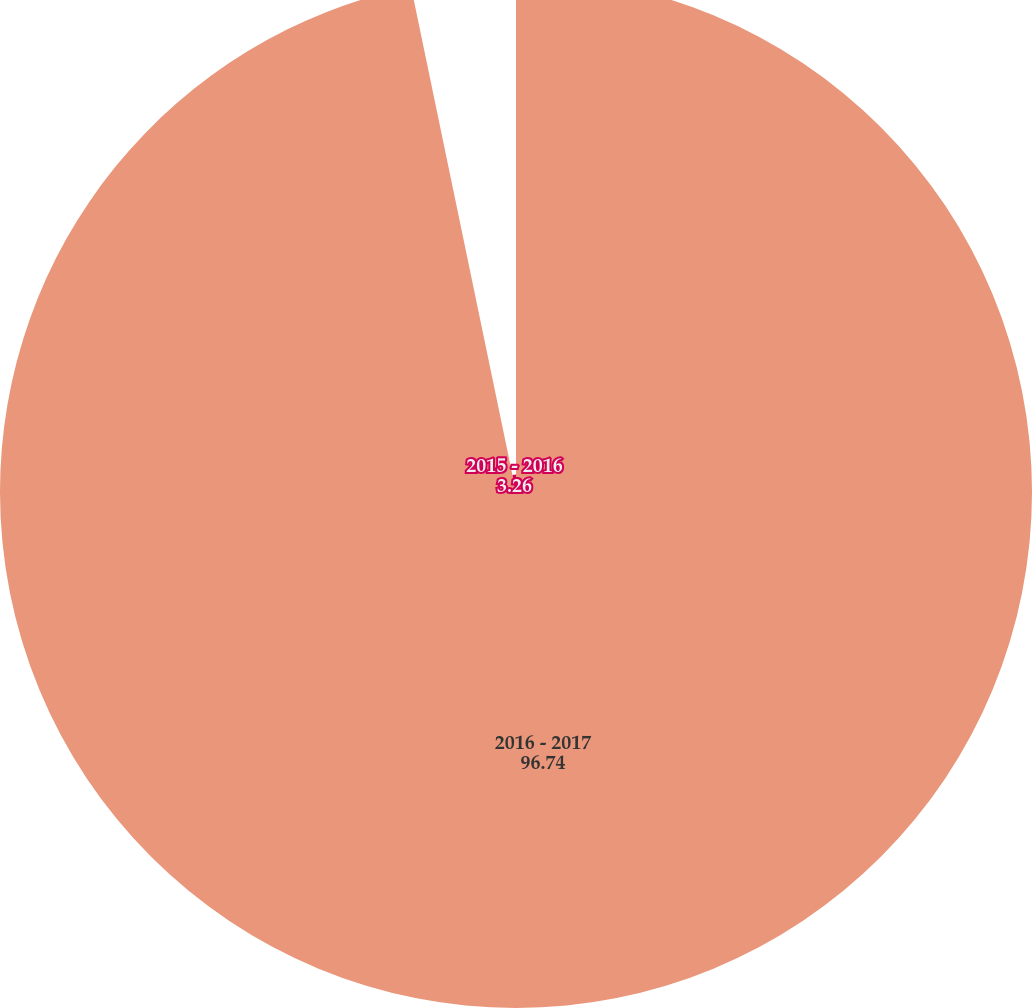Convert chart to OTSL. <chart><loc_0><loc_0><loc_500><loc_500><pie_chart><fcel>2016 - 2017<fcel>2015 - 2016<nl><fcel>96.74%<fcel>3.26%<nl></chart> 